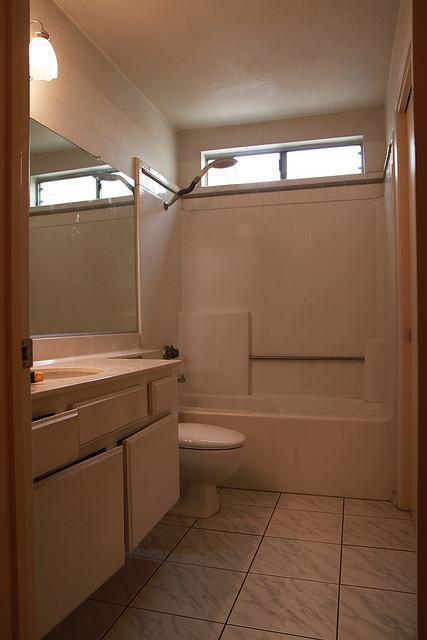How many chairs are under the wood board?
Give a very brief answer. 0. 